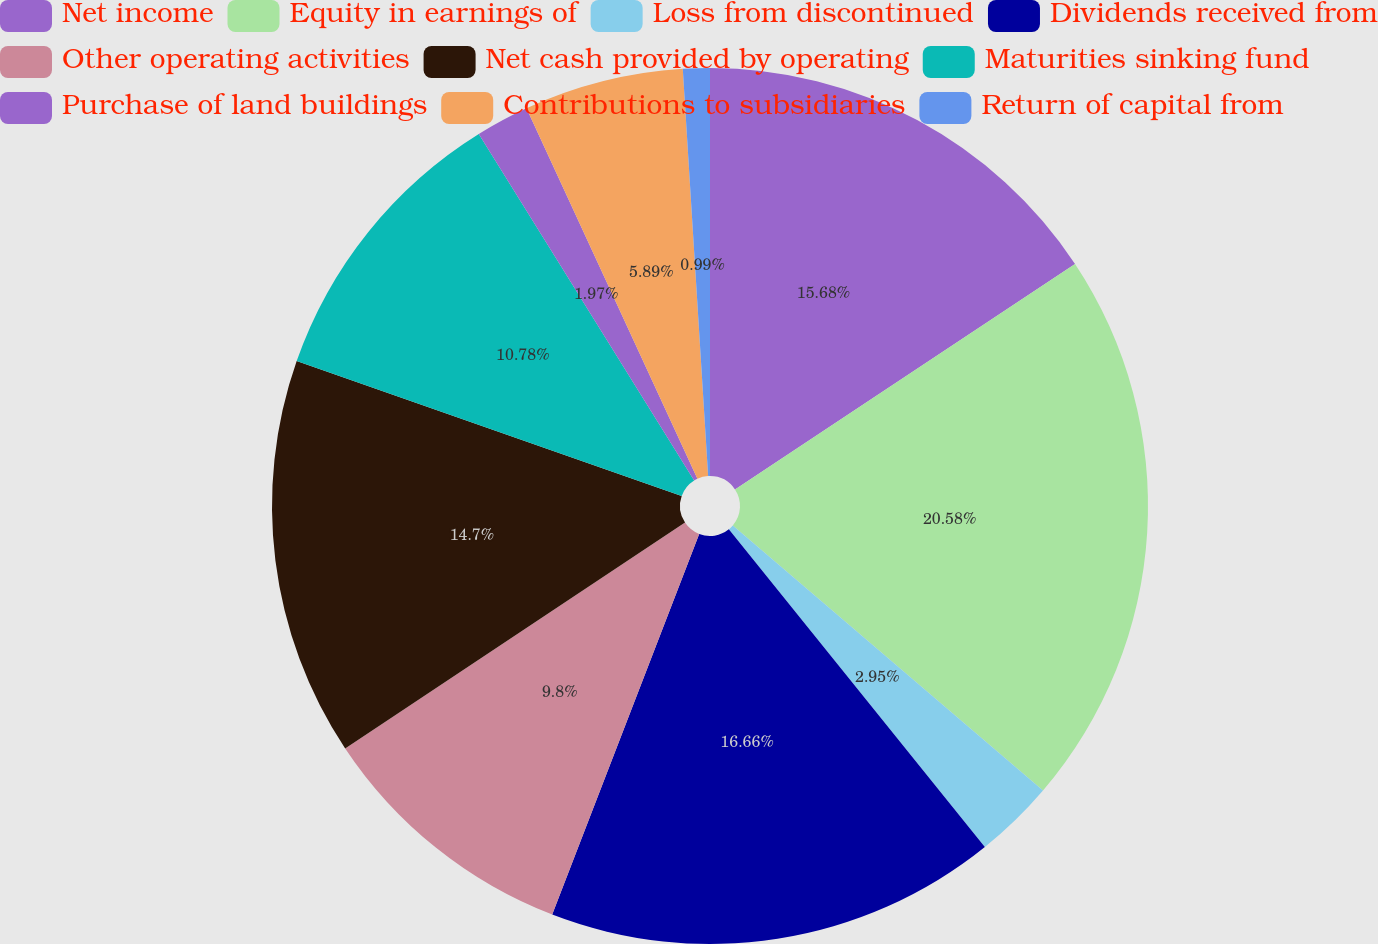<chart> <loc_0><loc_0><loc_500><loc_500><pie_chart><fcel>Net income<fcel>Equity in earnings of<fcel>Loss from discontinued<fcel>Dividends received from<fcel>Other operating activities<fcel>Net cash provided by operating<fcel>Maturities sinking fund<fcel>Purchase of land buildings<fcel>Contributions to subsidiaries<fcel>Return of capital from<nl><fcel>15.68%<fcel>20.57%<fcel>2.95%<fcel>16.66%<fcel>9.8%<fcel>14.7%<fcel>10.78%<fcel>1.97%<fcel>5.89%<fcel>0.99%<nl></chart> 